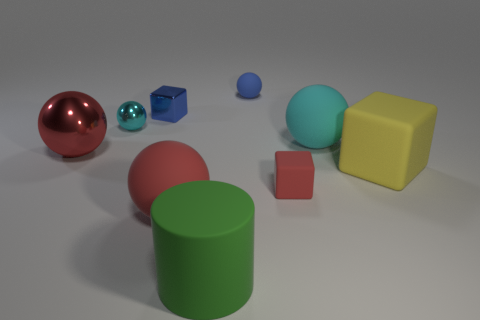How many big things are on the left side of the big yellow rubber block and on the right side of the small blue shiny object? 3 